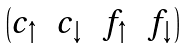Convert formula to latex. <formula><loc_0><loc_0><loc_500><loc_500>\begin{pmatrix} c _ { \uparrow } & c _ { \downarrow } & f _ { \uparrow } & f _ { \downarrow } \end{pmatrix}</formula> 